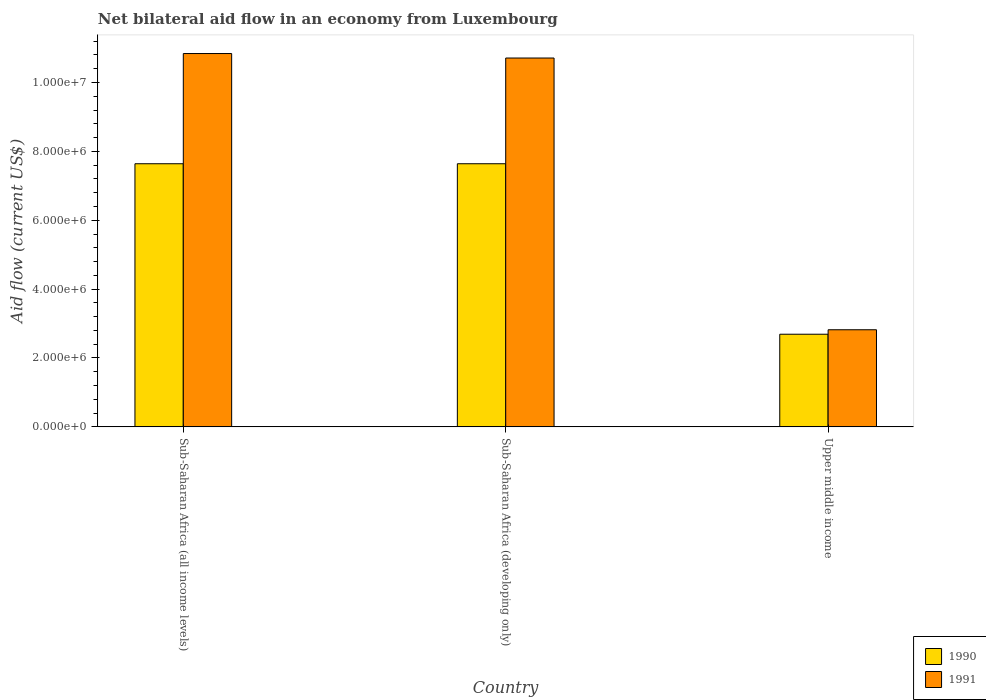How many different coloured bars are there?
Give a very brief answer. 2. How many groups of bars are there?
Your answer should be compact. 3. Are the number of bars per tick equal to the number of legend labels?
Your response must be concise. Yes. How many bars are there on the 3rd tick from the right?
Give a very brief answer. 2. What is the label of the 2nd group of bars from the left?
Give a very brief answer. Sub-Saharan Africa (developing only). In how many cases, is the number of bars for a given country not equal to the number of legend labels?
Keep it short and to the point. 0. What is the net bilateral aid flow in 1991 in Sub-Saharan Africa (all income levels)?
Your answer should be very brief. 1.08e+07. Across all countries, what is the maximum net bilateral aid flow in 1991?
Keep it short and to the point. 1.08e+07. Across all countries, what is the minimum net bilateral aid flow in 1990?
Your answer should be compact. 2.69e+06. In which country was the net bilateral aid flow in 1991 maximum?
Offer a terse response. Sub-Saharan Africa (all income levels). In which country was the net bilateral aid flow in 1990 minimum?
Provide a succinct answer. Upper middle income. What is the total net bilateral aid flow in 1991 in the graph?
Keep it short and to the point. 2.44e+07. What is the difference between the net bilateral aid flow in 1990 in Sub-Saharan Africa (developing only) and that in Upper middle income?
Your answer should be very brief. 4.95e+06. What is the difference between the net bilateral aid flow in 1990 in Sub-Saharan Africa (all income levels) and the net bilateral aid flow in 1991 in Sub-Saharan Africa (developing only)?
Your answer should be very brief. -3.07e+06. What is the average net bilateral aid flow in 1991 per country?
Give a very brief answer. 8.12e+06. What is the ratio of the net bilateral aid flow in 1991 in Sub-Saharan Africa (all income levels) to that in Upper middle income?
Keep it short and to the point. 3.84. Is the difference between the net bilateral aid flow in 1990 in Sub-Saharan Africa (developing only) and Upper middle income greater than the difference between the net bilateral aid flow in 1991 in Sub-Saharan Africa (developing only) and Upper middle income?
Your answer should be very brief. No. What is the difference between the highest and the second highest net bilateral aid flow in 1990?
Offer a very short reply. 4.95e+06. What is the difference between the highest and the lowest net bilateral aid flow in 1991?
Provide a succinct answer. 8.02e+06. In how many countries, is the net bilateral aid flow in 1991 greater than the average net bilateral aid flow in 1991 taken over all countries?
Ensure brevity in your answer.  2. What does the 2nd bar from the left in Upper middle income represents?
Keep it short and to the point. 1991. What does the 2nd bar from the right in Upper middle income represents?
Ensure brevity in your answer.  1990. How many countries are there in the graph?
Give a very brief answer. 3. What is the difference between two consecutive major ticks on the Y-axis?
Make the answer very short. 2.00e+06. How many legend labels are there?
Your answer should be compact. 2. What is the title of the graph?
Give a very brief answer. Net bilateral aid flow in an economy from Luxembourg. What is the label or title of the X-axis?
Provide a succinct answer. Country. What is the Aid flow (current US$) in 1990 in Sub-Saharan Africa (all income levels)?
Your response must be concise. 7.64e+06. What is the Aid flow (current US$) of 1991 in Sub-Saharan Africa (all income levels)?
Offer a very short reply. 1.08e+07. What is the Aid flow (current US$) in 1990 in Sub-Saharan Africa (developing only)?
Your answer should be compact. 7.64e+06. What is the Aid flow (current US$) in 1991 in Sub-Saharan Africa (developing only)?
Your answer should be compact. 1.07e+07. What is the Aid flow (current US$) in 1990 in Upper middle income?
Ensure brevity in your answer.  2.69e+06. What is the Aid flow (current US$) in 1991 in Upper middle income?
Keep it short and to the point. 2.82e+06. Across all countries, what is the maximum Aid flow (current US$) in 1990?
Your response must be concise. 7.64e+06. Across all countries, what is the maximum Aid flow (current US$) in 1991?
Offer a terse response. 1.08e+07. Across all countries, what is the minimum Aid flow (current US$) of 1990?
Your response must be concise. 2.69e+06. Across all countries, what is the minimum Aid flow (current US$) in 1991?
Keep it short and to the point. 2.82e+06. What is the total Aid flow (current US$) of 1990 in the graph?
Your answer should be compact. 1.80e+07. What is the total Aid flow (current US$) in 1991 in the graph?
Keep it short and to the point. 2.44e+07. What is the difference between the Aid flow (current US$) of 1990 in Sub-Saharan Africa (all income levels) and that in Upper middle income?
Your answer should be compact. 4.95e+06. What is the difference between the Aid flow (current US$) in 1991 in Sub-Saharan Africa (all income levels) and that in Upper middle income?
Give a very brief answer. 8.02e+06. What is the difference between the Aid flow (current US$) of 1990 in Sub-Saharan Africa (developing only) and that in Upper middle income?
Offer a very short reply. 4.95e+06. What is the difference between the Aid flow (current US$) in 1991 in Sub-Saharan Africa (developing only) and that in Upper middle income?
Your answer should be very brief. 7.89e+06. What is the difference between the Aid flow (current US$) in 1990 in Sub-Saharan Africa (all income levels) and the Aid flow (current US$) in 1991 in Sub-Saharan Africa (developing only)?
Your answer should be compact. -3.07e+06. What is the difference between the Aid flow (current US$) of 1990 in Sub-Saharan Africa (all income levels) and the Aid flow (current US$) of 1991 in Upper middle income?
Your response must be concise. 4.82e+06. What is the difference between the Aid flow (current US$) in 1990 in Sub-Saharan Africa (developing only) and the Aid flow (current US$) in 1991 in Upper middle income?
Ensure brevity in your answer.  4.82e+06. What is the average Aid flow (current US$) of 1990 per country?
Make the answer very short. 5.99e+06. What is the average Aid flow (current US$) of 1991 per country?
Offer a very short reply. 8.12e+06. What is the difference between the Aid flow (current US$) in 1990 and Aid flow (current US$) in 1991 in Sub-Saharan Africa (all income levels)?
Make the answer very short. -3.20e+06. What is the difference between the Aid flow (current US$) in 1990 and Aid flow (current US$) in 1991 in Sub-Saharan Africa (developing only)?
Ensure brevity in your answer.  -3.07e+06. What is the ratio of the Aid flow (current US$) in 1991 in Sub-Saharan Africa (all income levels) to that in Sub-Saharan Africa (developing only)?
Offer a terse response. 1.01. What is the ratio of the Aid flow (current US$) in 1990 in Sub-Saharan Africa (all income levels) to that in Upper middle income?
Your response must be concise. 2.84. What is the ratio of the Aid flow (current US$) of 1991 in Sub-Saharan Africa (all income levels) to that in Upper middle income?
Provide a short and direct response. 3.84. What is the ratio of the Aid flow (current US$) in 1990 in Sub-Saharan Africa (developing only) to that in Upper middle income?
Make the answer very short. 2.84. What is the ratio of the Aid flow (current US$) of 1991 in Sub-Saharan Africa (developing only) to that in Upper middle income?
Provide a succinct answer. 3.8. What is the difference between the highest and the second highest Aid flow (current US$) in 1990?
Ensure brevity in your answer.  0. What is the difference between the highest and the lowest Aid flow (current US$) of 1990?
Ensure brevity in your answer.  4.95e+06. What is the difference between the highest and the lowest Aid flow (current US$) of 1991?
Your response must be concise. 8.02e+06. 